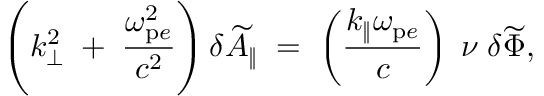Convert formula to latex. <formula><loc_0><loc_0><loc_500><loc_500>\left ( k _ { \bot } ^ { 2 } \, + \, \frac { \omega _ { p e } ^ { 2 } } { c ^ { 2 } } \right ) \delta \widetilde { A } _ { \| } \, = \, \left ( \frac { k _ { \| } \omega _ { p e } } { c } \right ) \, \nu \, \delta \widetilde { \Phi } ,</formula> 